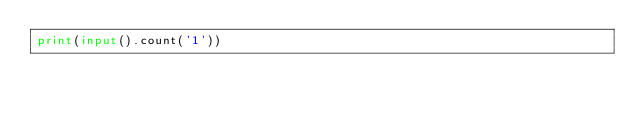Convert code to text. <code><loc_0><loc_0><loc_500><loc_500><_Python_>print(input().count('1'))</code> 